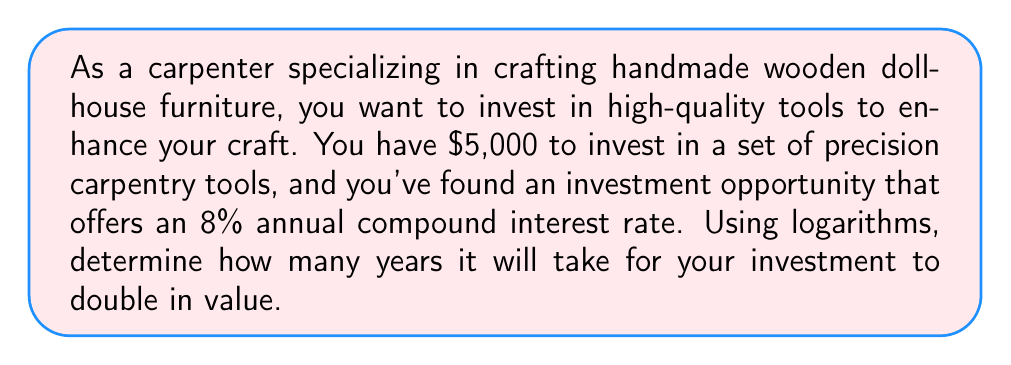Could you help me with this problem? To solve this problem, we'll use the compound interest formula and logarithms:

1) The compound interest formula is:
   $A = P(1 + r)^t$
   Where:
   $A$ = Final amount
   $P$ = Principal (initial investment)
   $r$ = Annual interest rate (as a decimal)
   $t$ = Time in years

2) We want to find when the amount doubles, so:
   $2P = P(1 + r)^t$

3) Simplify by dividing both sides by $P$:
   $2 = (1 + r)^t$

4) Take the natural logarithm of both sides:
   $\ln(2) = \ln((1 + r)^t)$

5) Use the logarithm property $\ln(a^b) = b\ln(a)$:
   $\ln(2) = t\ln(1 + r)$

6) Solve for $t$ by dividing both sides by $\ln(1 + r)$:
   $t = \frac{\ln(2)}{\ln(1 + r)}$

7) Now, plug in the values:
   $r = 0.08$ (8% as a decimal)

   $$t = \frac{\ln(2)}{\ln(1 + 0.08)} = \frac{0.693147}{0.076961} \approx 9.006$$

8) Round to the nearest hundredth:
   $t \approx 9.01$ years
Answer: It will take approximately 9.01 years for the $5,000 investment in carpentry tools to double in value at an 8% annual compound interest rate. 